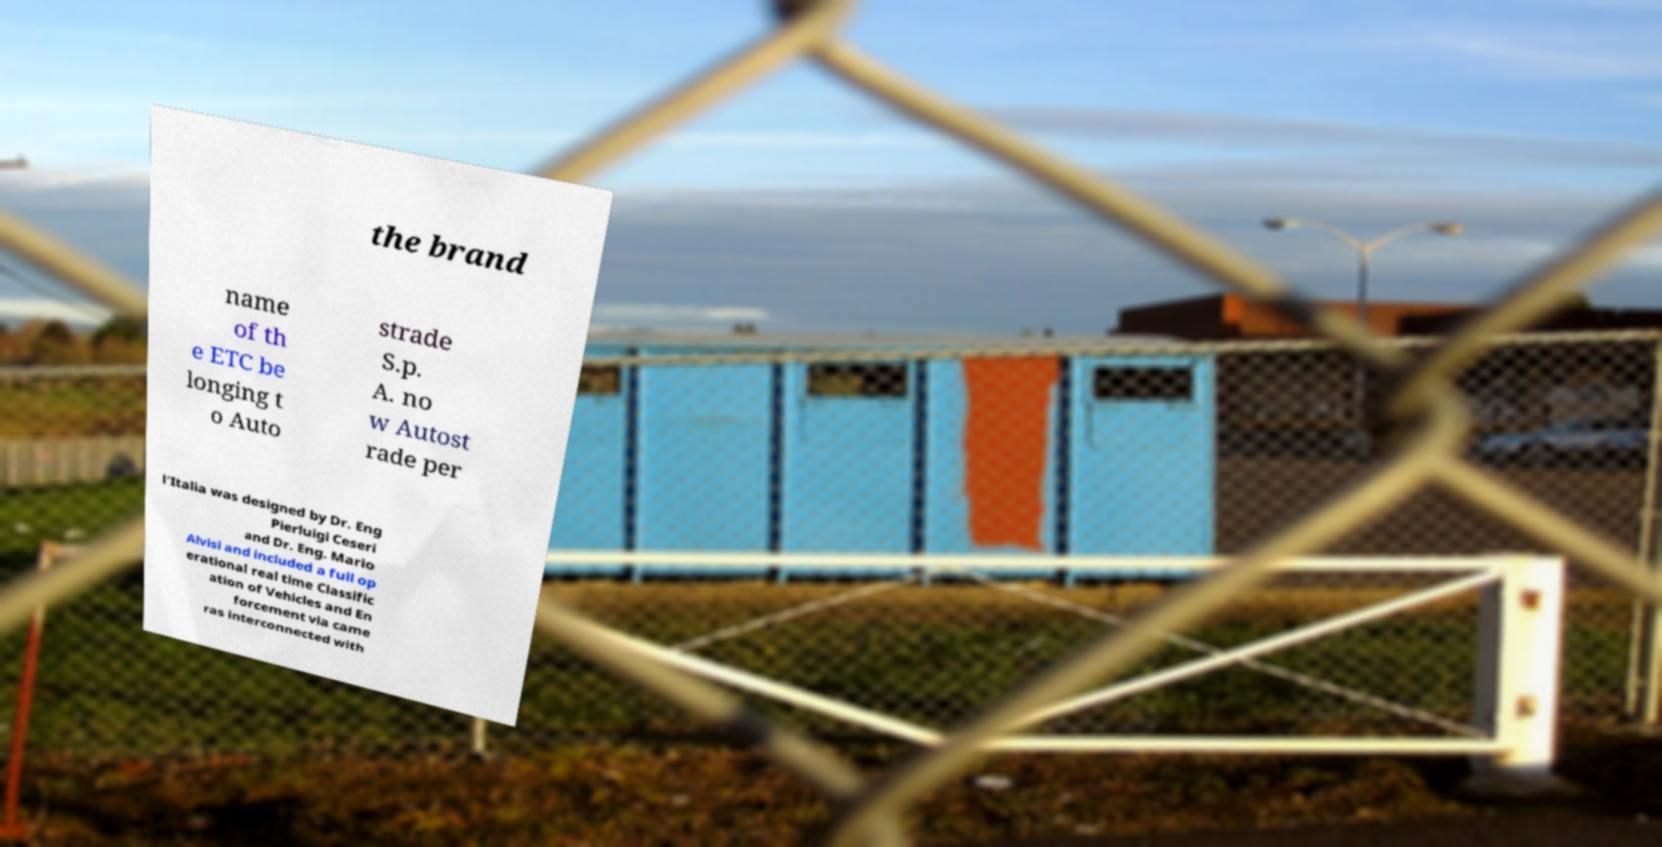Please read and relay the text visible in this image. What does it say? the brand name of th e ETC be longing t o Auto strade S.p. A. no w Autost rade per l'Italia was designed by Dr. Eng Pierluigi Ceseri and Dr. Eng. Mario Alvisi and included a full op erational real time Classific ation of Vehicles and En forcement via came ras interconnected with 